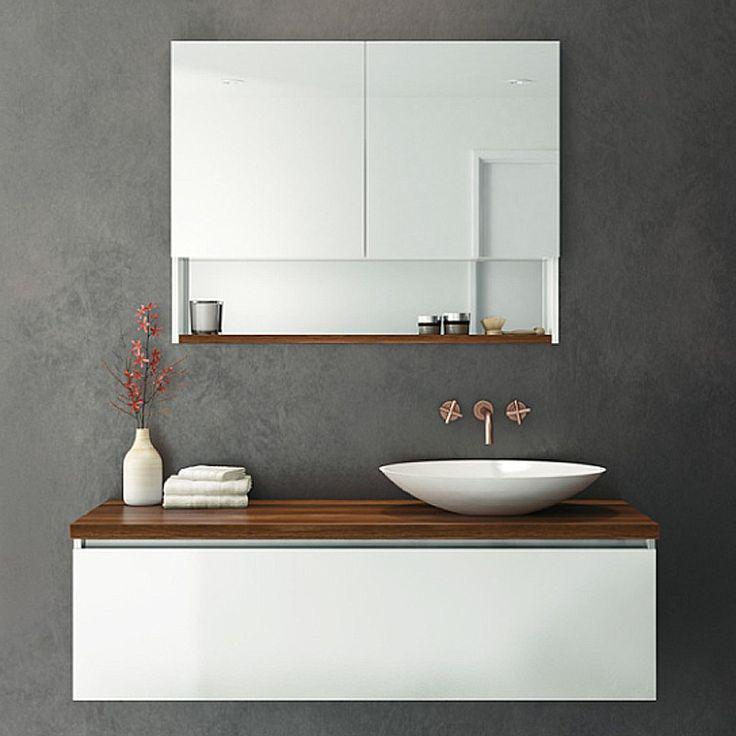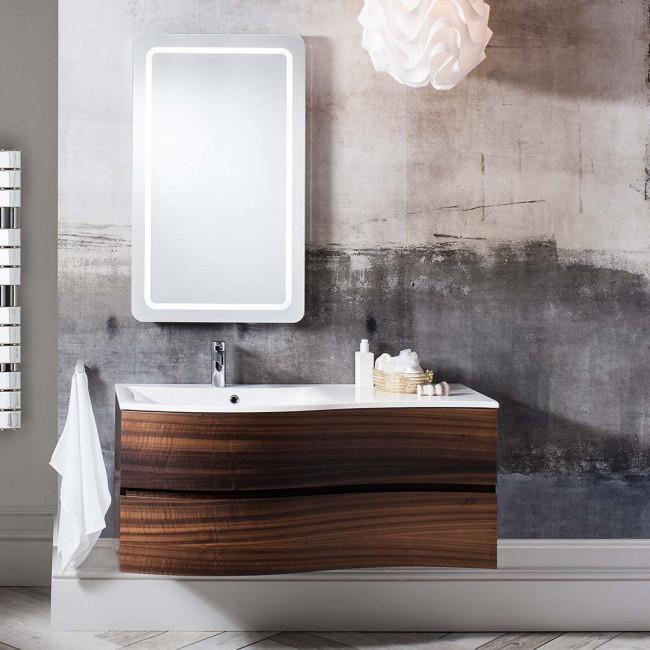The first image is the image on the left, the second image is the image on the right. Considering the images on both sides, is "At least one of the sinks has a floral arrangement next to it." valid? Answer yes or no. Yes. 